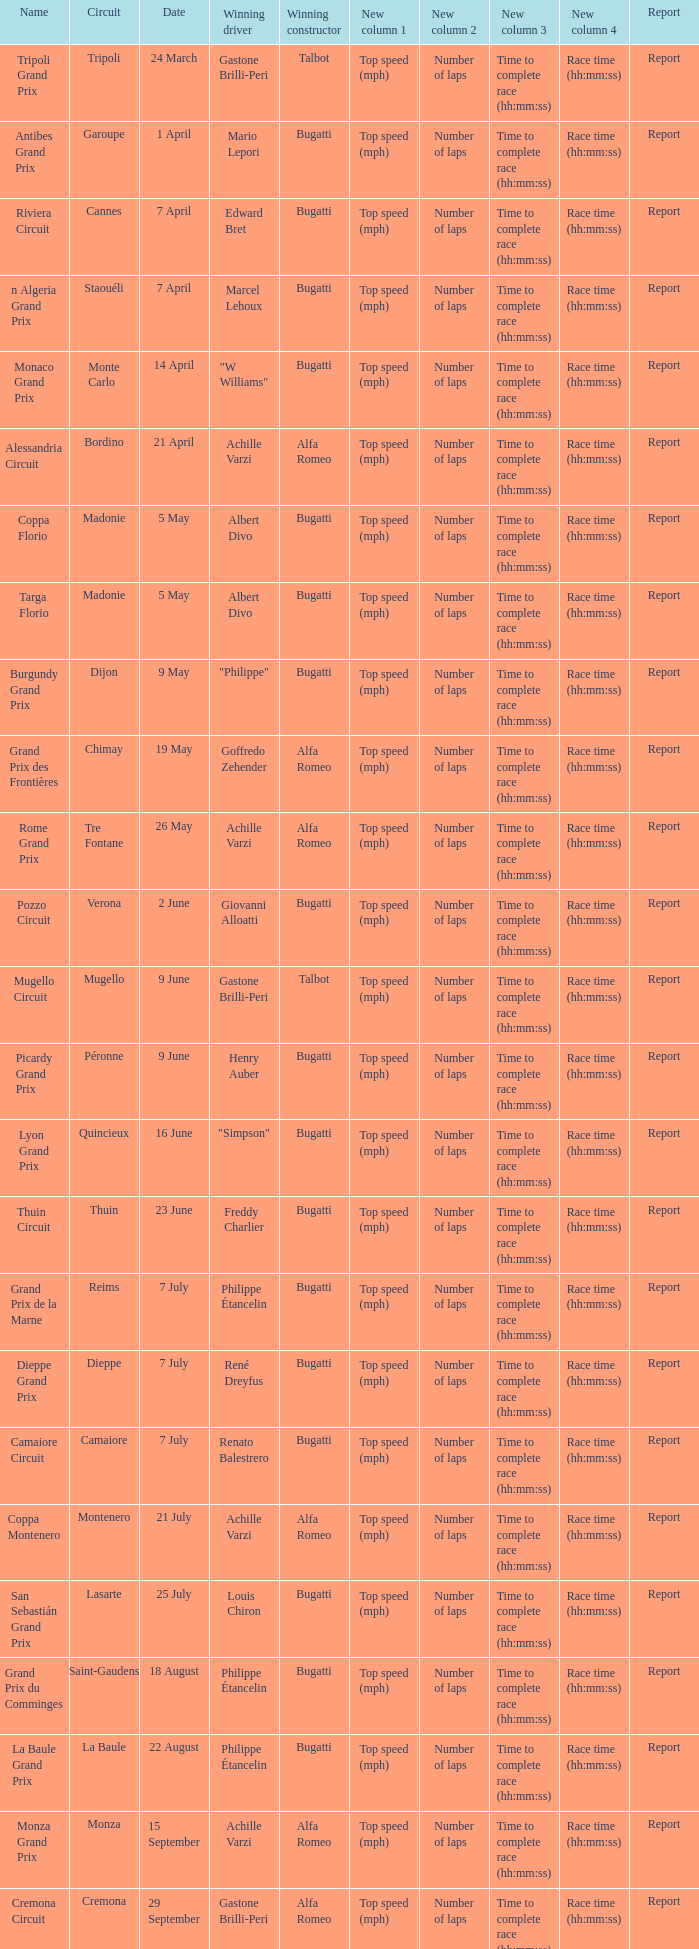What Winning driver has a Name of mugello circuit? Gastone Brilli-Peri. 